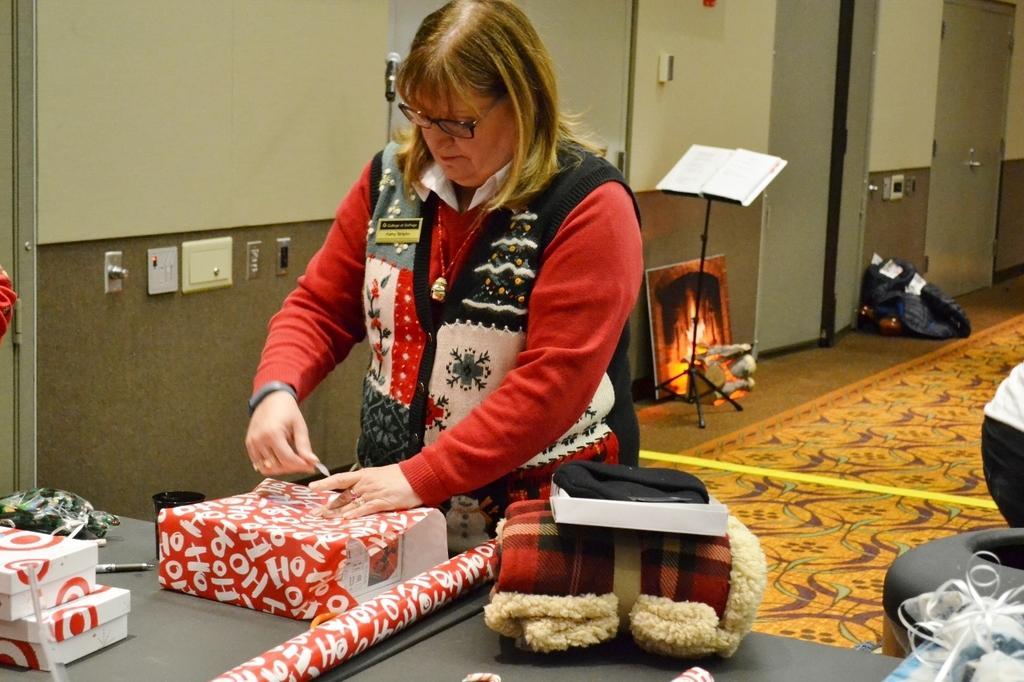Describe this image in one or two sentences. This image consists of a woman wearing a red dress. She is packing the gifts. At the bottom, there is floor mat on the floor. In the background, we can see a wall along with doors and a book stand. On the right, it looks like a sofa. At the bottom, there is a table on which there are many things kept. 